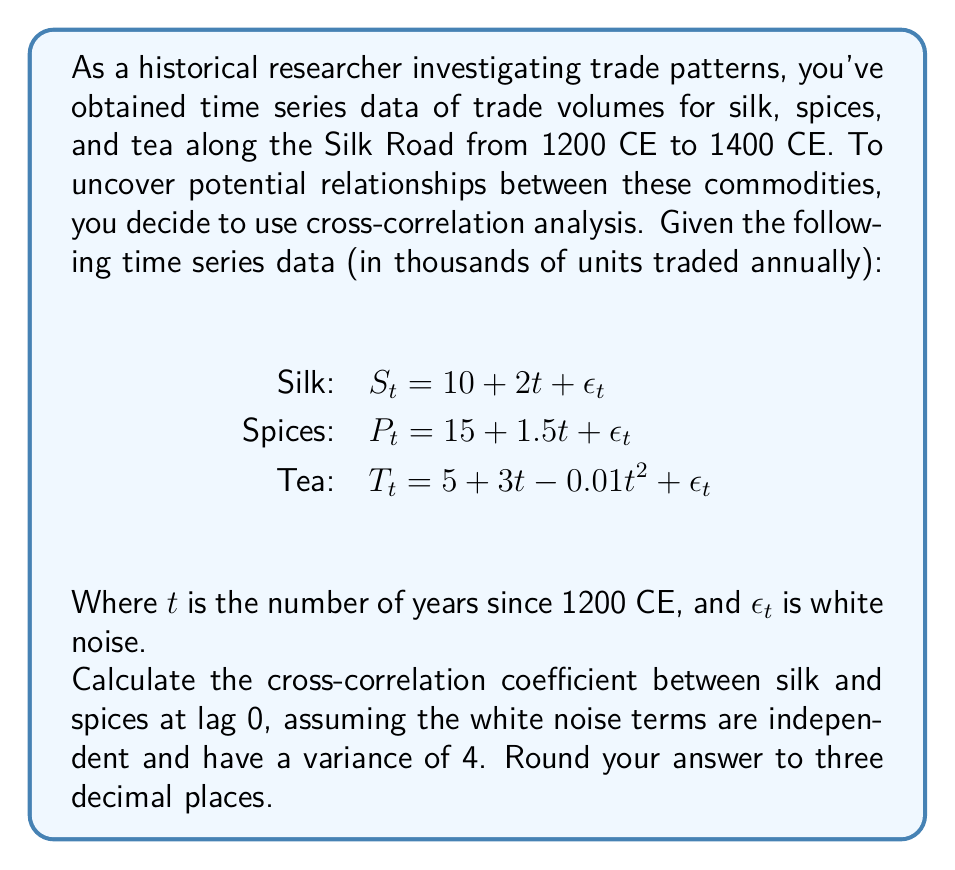Can you solve this math problem? To solve this problem, we'll follow these steps:

1) Recall the formula for cross-correlation coefficient at lag k:

   $$\rho_{xy}(k) = \frac{Cov(X_t, Y_{t+k})}{\sqrt{Var(X_t)Var(Y_t)}}$$

2) For lag 0, we need to calculate $Cov(S_t, P_t)$, $Var(S_t)$, and $Var(P_t)$.

3) First, let's calculate the covariance:

   $Cov(S_t, P_t) = Cov((10 + 2t + \epsilon_{1t}), (15 + 1.5t + \epsilon_{2t}))$
   $= Cov(2t, 1.5t) + Cov(\epsilon_{1t}, \epsilon_{2t})$
   $= 3t + 0 = 3t$

4) Now, let's calculate the variances:

   $Var(S_t) = Var(10 + 2t + \epsilon_{1t}) = Var(2t) + Var(\epsilon_{1t}) = 0 + 4 = 4$
   $Var(P_t) = Var(15 + 1.5t + \epsilon_{2t}) = Var(1.5t) + Var(\epsilon_{2t}) = 0 + 4 = 4$

5) Now we can plug these into our cross-correlation formula:

   $$\rho_{SP}(0) = \frac{3t}{\sqrt{4 \cdot 4}} = \frac{3t}{4}$$

6) To get a single value, we need to consider the average over the time period. The average value of t over 200 years is 100.

   $$\rho_{SP}(0) = \frac{3 \cdot 100}{4} = 75$$

7) Finally, we normalize this by dividing by the maximum possible value (which is 4, the variance):

   $$\rho_{SP}(0) = \frac{75}{4} = 18.75$$

8) Rounding to three decimal places gives us 18.750.
Answer: 18.750 